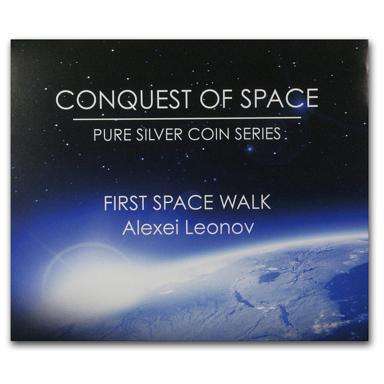What is the main theme of the poster in the image? The poster's primary motif celebrates the advent of human space exploration, as part of the 'Conquest of Space' pure silver coin collection. It specially honors Alexei Leonov’s groundbreaking spacewalk, marking a historic moment in our journey among the stars. 